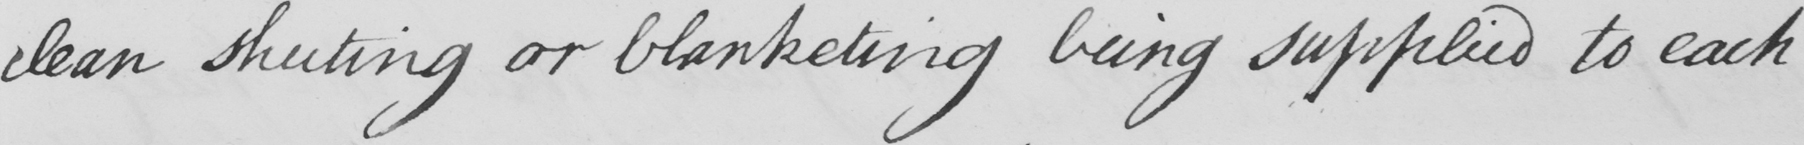Transcribe the text shown in this historical manuscript line. clean sheeting or blanketing being supplied to each 